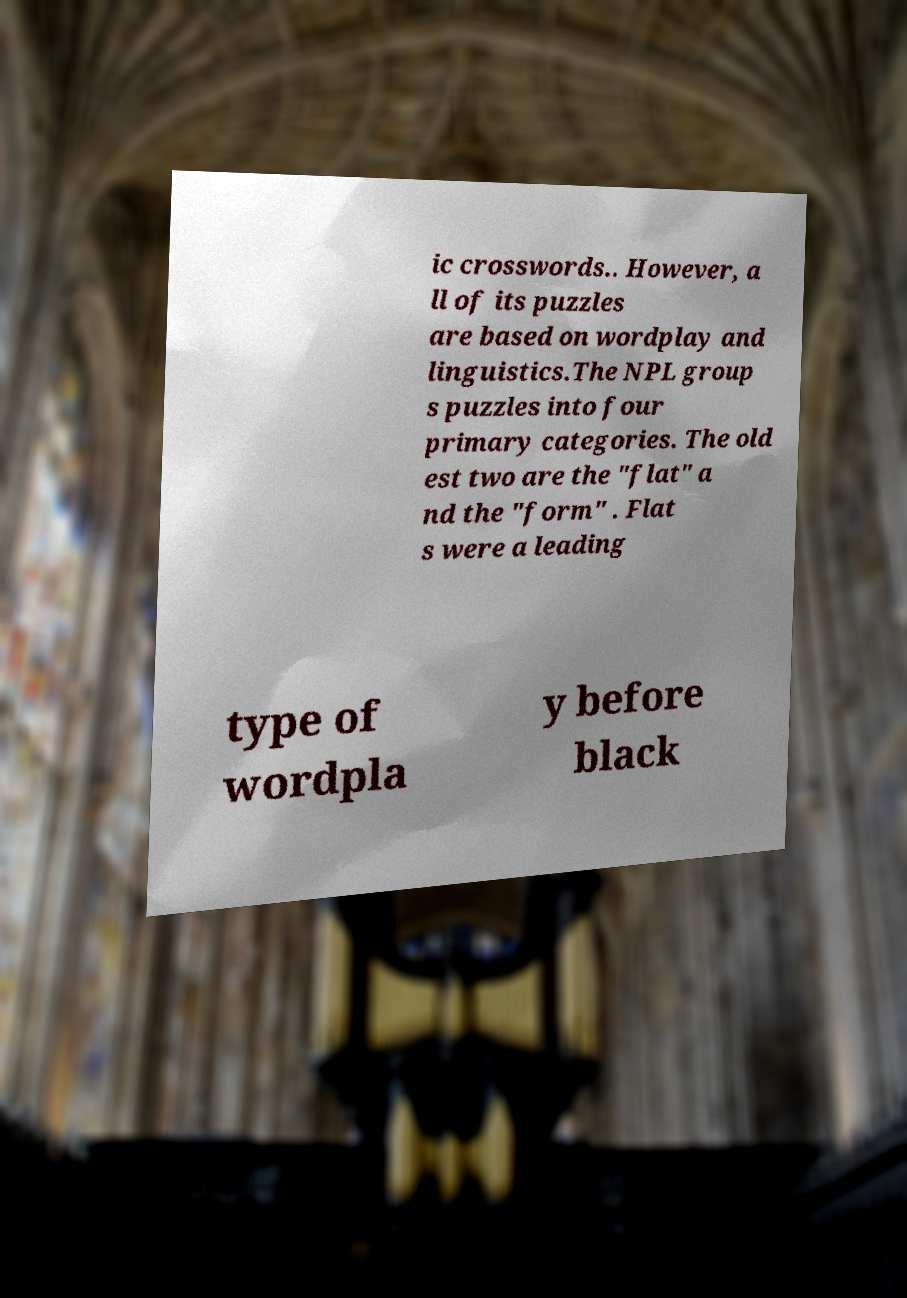Can you accurately transcribe the text from the provided image for me? ic crosswords.. However, a ll of its puzzles are based on wordplay and linguistics.The NPL group s puzzles into four primary categories. The old est two are the "flat" a nd the "form" . Flat s were a leading type of wordpla y before black 